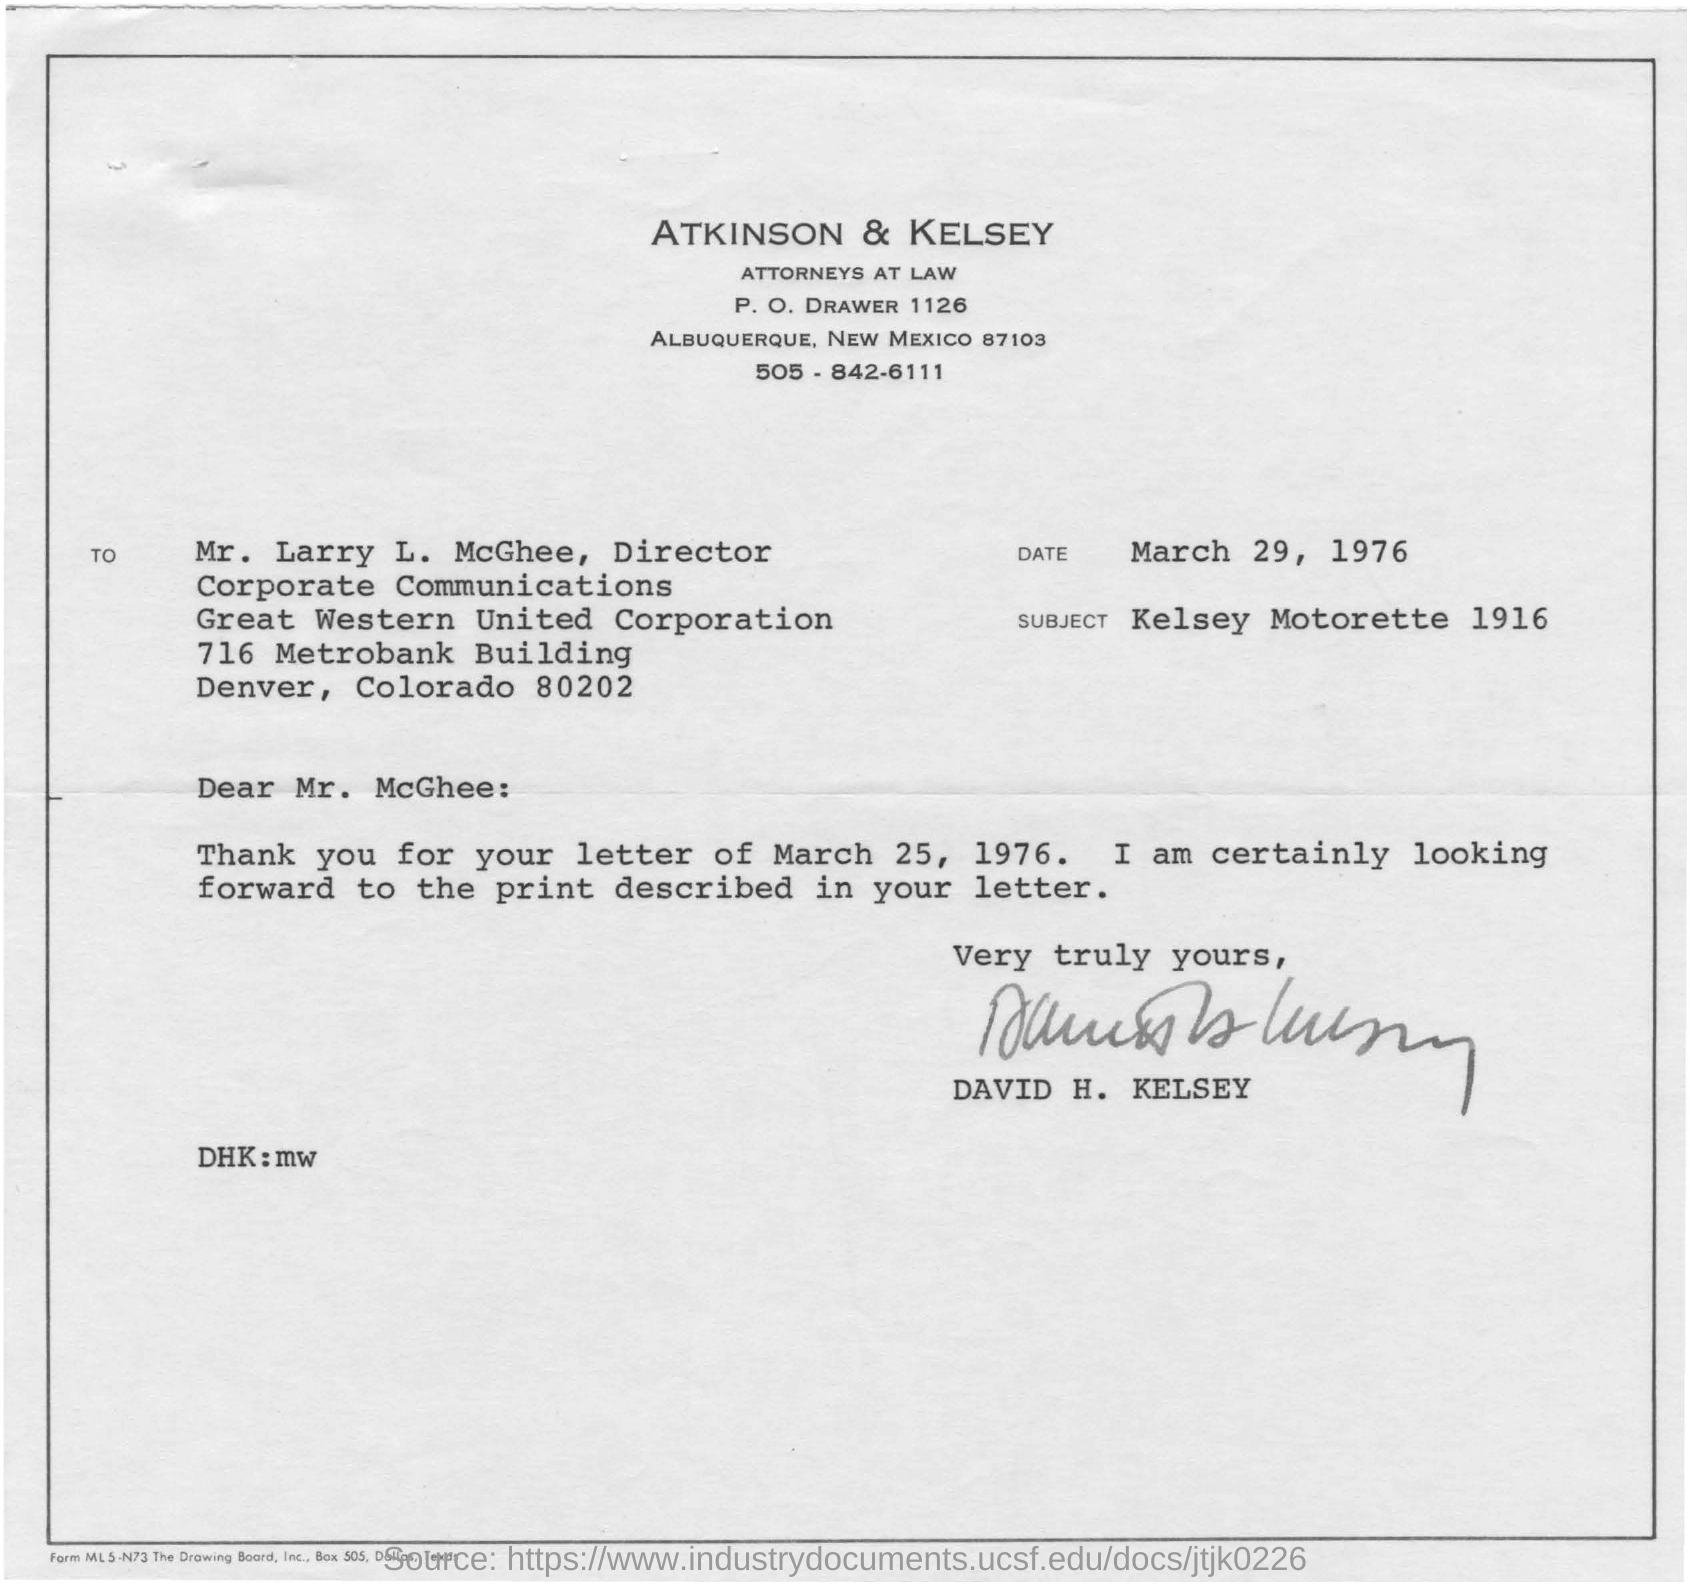Outline some significant characteristics in this image. This document was written by David H. Kelsey. The date mentioned is March 29, 1976. The subject of the document is Kelsey Motorette 1916. 